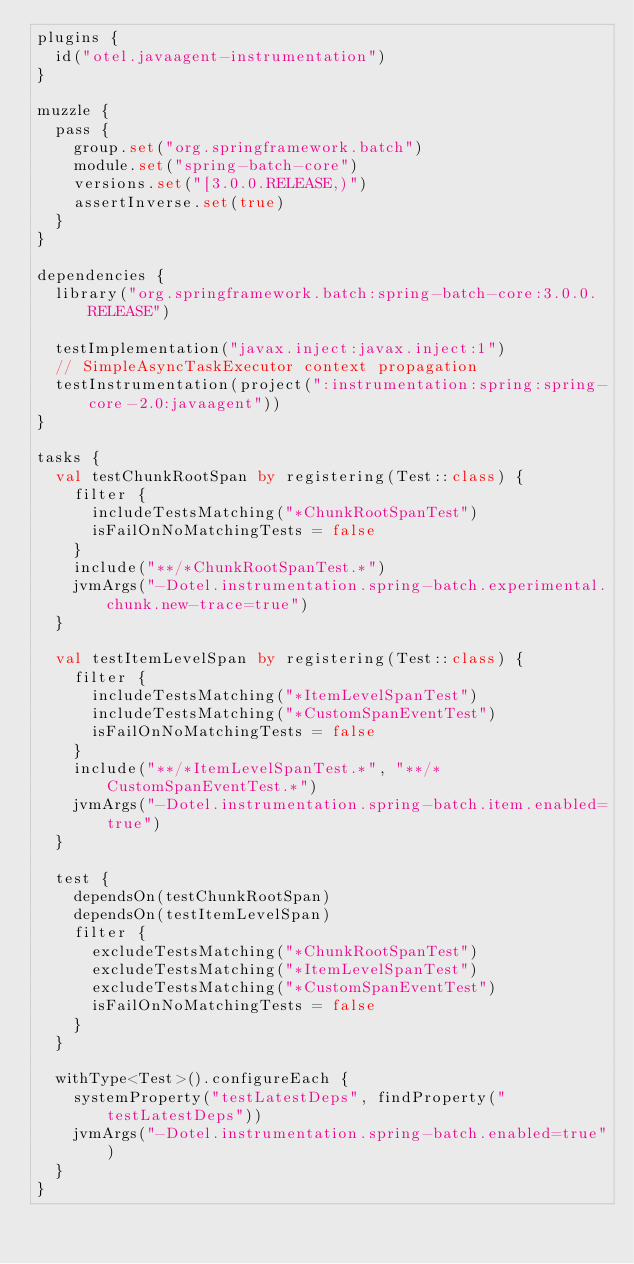<code> <loc_0><loc_0><loc_500><loc_500><_Kotlin_>plugins {
  id("otel.javaagent-instrumentation")
}

muzzle {
  pass {
    group.set("org.springframework.batch")
    module.set("spring-batch-core")
    versions.set("[3.0.0.RELEASE,)")
    assertInverse.set(true)
  }
}

dependencies {
  library("org.springframework.batch:spring-batch-core:3.0.0.RELEASE")

  testImplementation("javax.inject:javax.inject:1")
  // SimpleAsyncTaskExecutor context propagation
  testInstrumentation(project(":instrumentation:spring:spring-core-2.0:javaagent"))
}

tasks {
  val testChunkRootSpan by registering(Test::class) {
    filter {
      includeTestsMatching("*ChunkRootSpanTest")
      isFailOnNoMatchingTests = false
    }
    include("**/*ChunkRootSpanTest.*")
    jvmArgs("-Dotel.instrumentation.spring-batch.experimental.chunk.new-trace=true")
  }

  val testItemLevelSpan by registering(Test::class) {
    filter {
      includeTestsMatching("*ItemLevelSpanTest")
      includeTestsMatching("*CustomSpanEventTest")
      isFailOnNoMatchingTests = false
    }
    include("**/*ItemLevelSpanTest.*", "**/*CustomSpanEventTest.*")
    jvmArgs("-Dotel.instrumentation.spring-batch.item.enabled=true")
  }

  test {
    dependsOn(testChunkRootSpan)
    dependsOn(testItemLevelSpan)
    filter {
      excludeTestsMatching("*ChunkRootSpanTest")
      excludeTestsMatching("*ItemLevelSpanTest")
      excludeTestsMatching("*CustomSpanEventTest")
      isFailOnNoMatchingTests = false
    }
  }

  withType<Test>().configureEach {
    systemProperty("testLatestDeps", findProperty("testLatestDeps"))
    jvmArgs("-Dotel.instrumentation.spring-batch.enabled=true")
  }
}
</code> 